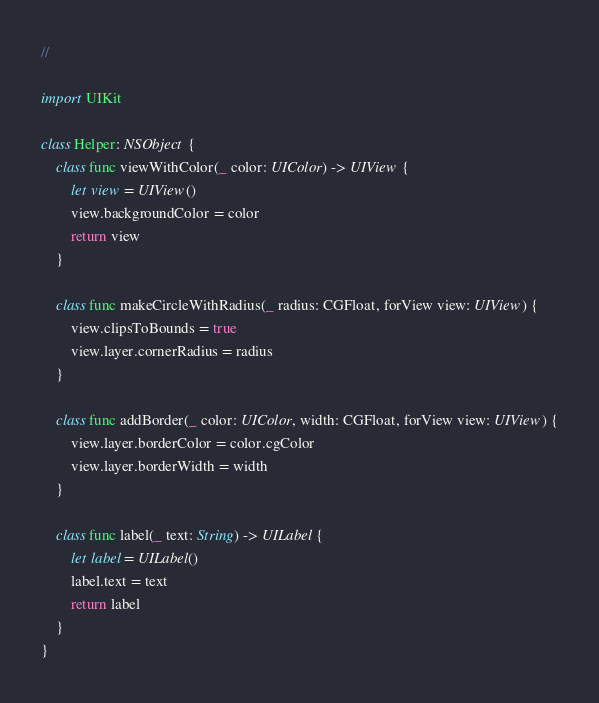Convert code to text. <code><loc_0><loc_0><loc_500><loc_500><_Swift_>//

import UIKit

class Helper: NSObject {
    class func viewWithColor(_ color: UIColor) -> UIView {
        let view = UIView()
        view.backgroundColor = color
        return view
    }
    
    class func makeCircleWithRadius(_ radius: CGFloat, forView view: UIView) {
        view.clipsToBounds = true
        view.layer.cornerRadius = radius
    }
    
    class func addBorder(_ color: UIColor, width: CGFloat, forView view: UIView) {
        view.layer.borderColor = color.cgColor
        view.layer.borderWidth = width
    }
    
    class func label(_ text: String) -> UILabel {
        let label = UILabel()
        label.text = text
        return label
    }
}
</code> 